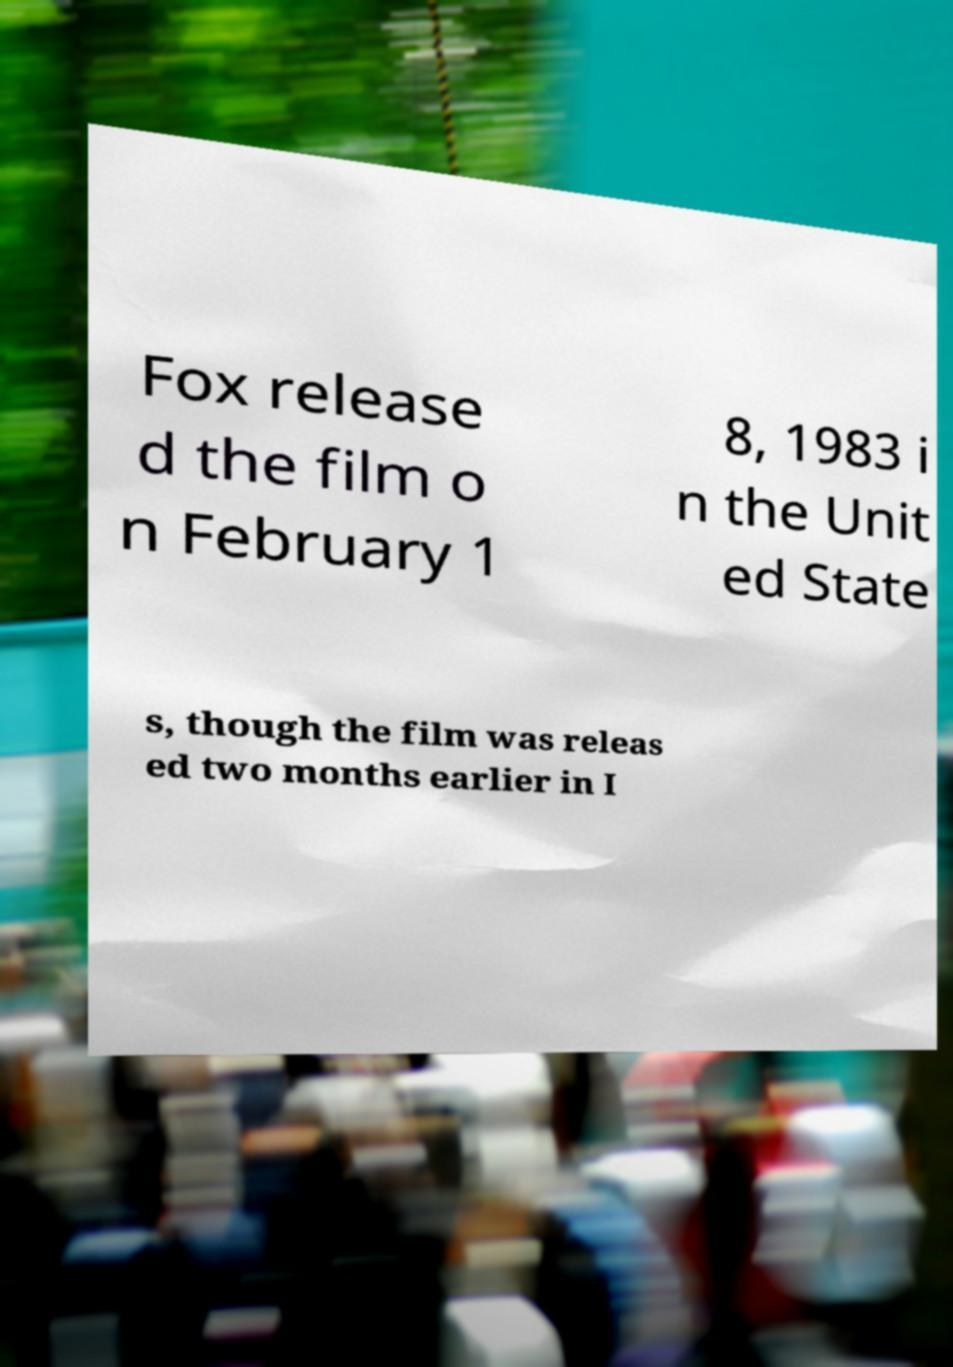Could you extract and type out the text from this image? Fox release d the film o n February 1 8, 1983 i n the Unit ed State s, though the film was releas ed two months earlier in I 